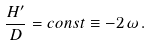<formula> <loc_0><loc_0><loc_500><loc_500>\frac { H ^ { \prime } } { D } = c o n s t \equiv - 2 \, \omega \, .</formula> 